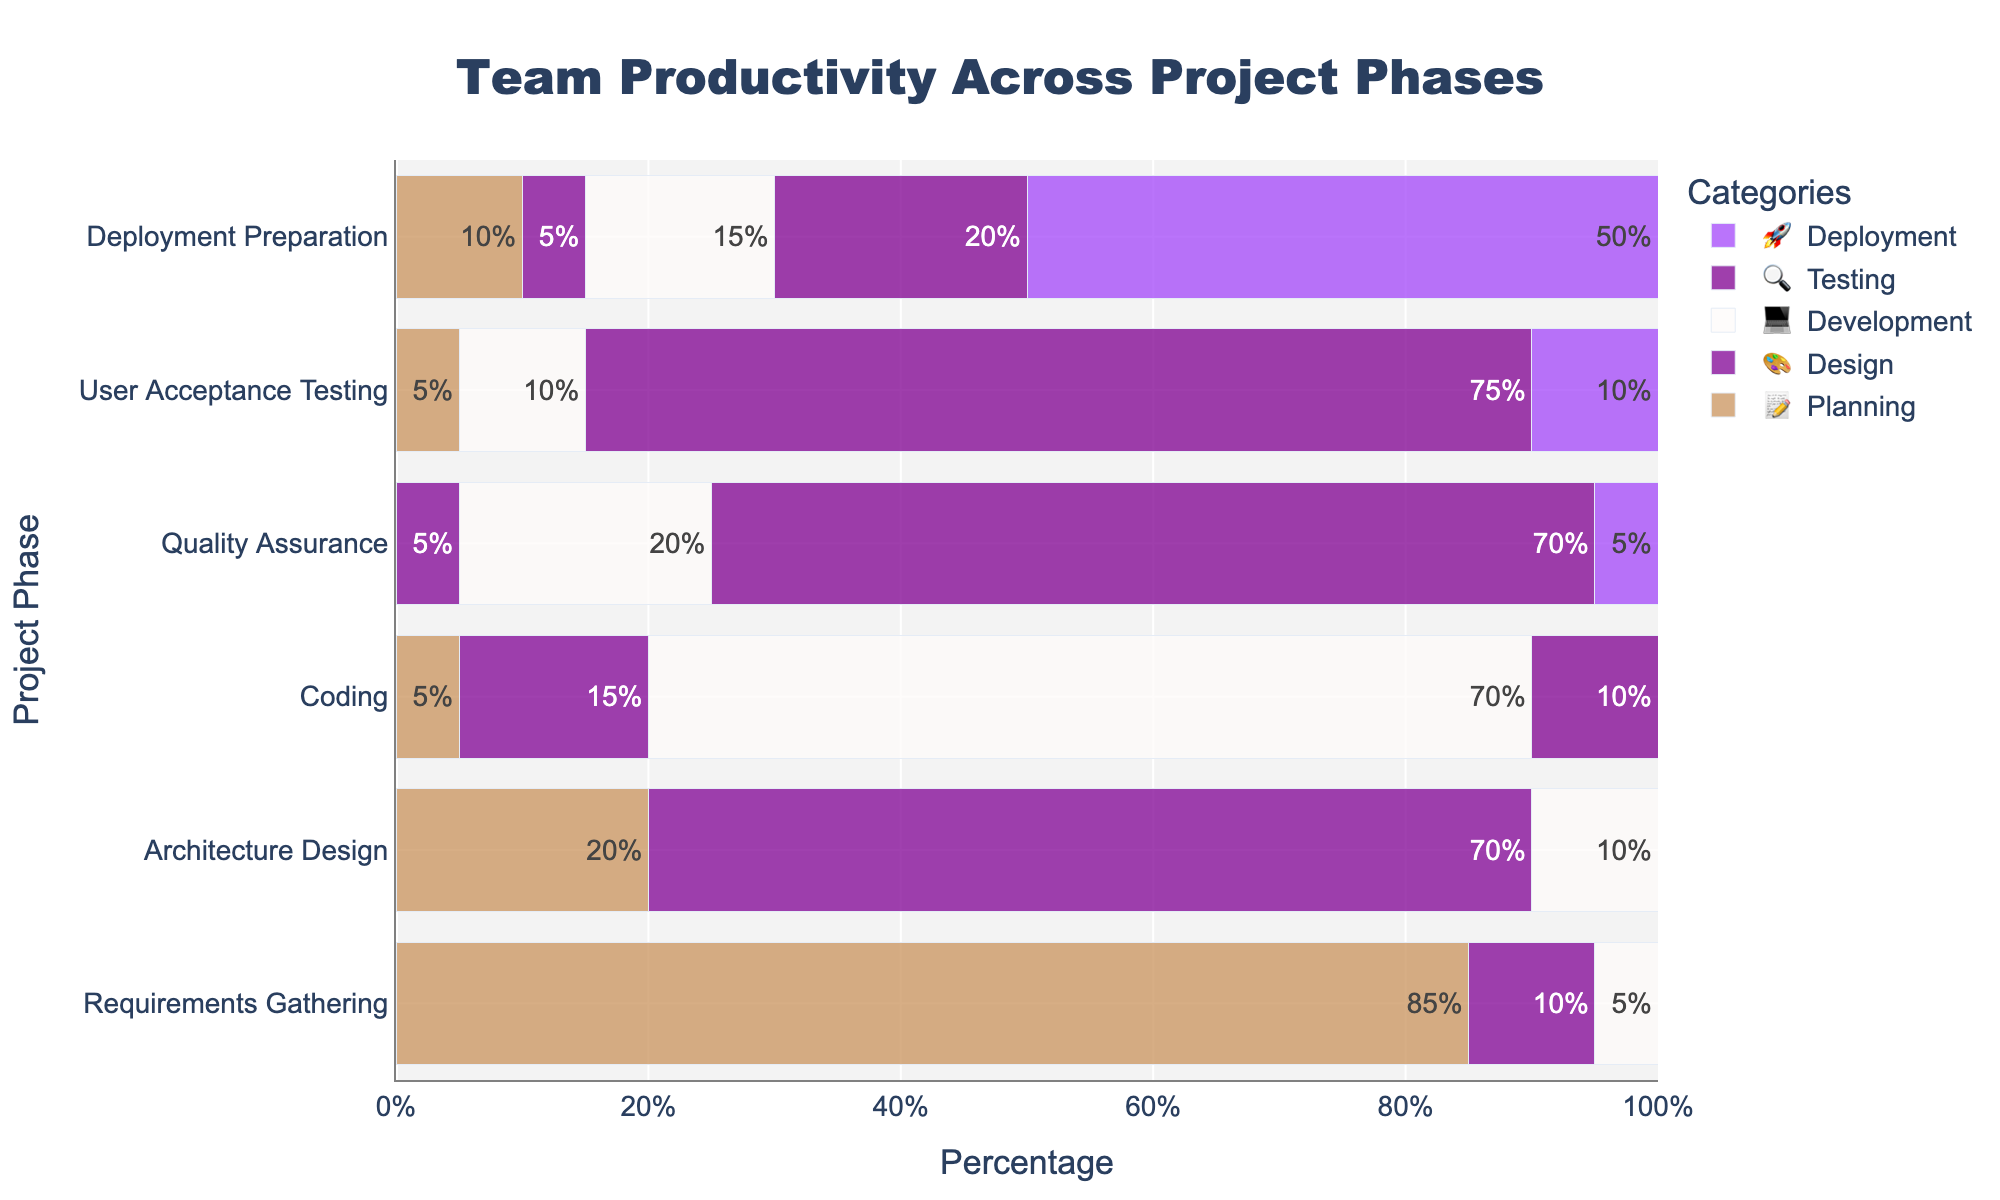How many phases are there in the project? There are six rows in the figure, each representing a different project phase. Count the rows to determine the number of phases.
Answer: 6 Which phase spends the highest percentage on 'Coding'? Look for the 'Coding' label and check the percentage values for all phases. The 'Coding' phase itself has the highest value at 70%.
Answer: Coding What is the percentage of 'Quality Assurance' for 'Testing'? Locate the 'Quality Assurance' phase and then find the percentage under the 'Testing' (🔍) category.
Answer: 70% Which phase has the highest percentage for 'Deployment'? Look for the 'Deployment' (🚀) label across all rows. The 'Deployment Preparation' phase has the highest value at 50%.
Answer: Deployment Preparation Compare the 'Planning' percentage between 'Requirements Gathering' and 'Deployment Preparation' phases. Look at the 'Planning' (📝) percentage for both phases. 'Requirements Gathering' has 85% and 'Deployment Preparation' has 10%.
Answer: 85% vs 10% During which phase is 'Design' most dominant? Check the 'Design' (🎨) label and find the highest percentage value. The 'Architecture Design' phase has the highest at 70%.
Answer: Architecture Design Sum the percentage of 'Development' for 'Quality Assurance' and 'User Acceptance Testing'. Locate the 'Development' percentages for both phases: 'Quality Assurance' has 20% and 'User Acceptance Testing' has 10%. Add them together: 20% + 10%.
Answer: 30% What is the total percentage of 'Testing' in the 'User Acceptance Testing' phase compared to 'Deployment Preparation'? Check the 'Testing' percentages: 'User Acceptance Testing' has 75%, and 'Deployment Preparation' has 20%.
Answer: 75% vs 20% Which phase allocates the lowest percentage for 'Planning'? Look at the 'Planning' (📝) percentages across all phases. The 'Quality Assurance' phase has 0%, which is the lowest.
Answer: Quality Assurance 